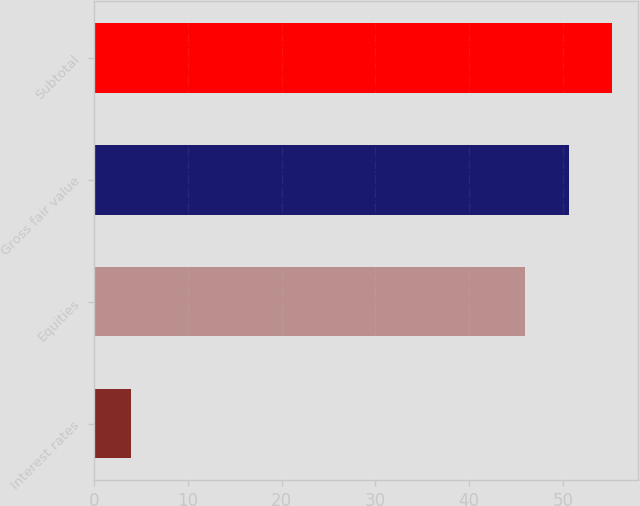Convert chart to OTSL. <chart><loc_0><loc_0><loc_500><loc_500><bar_chart><fcel>Interest rates<fcel>Equities<fcel>Gross fair value<fcel>Subtotal<nl><fcel>4<fcel>46<fcel>50.6<fcel>55.2<nl></chart> 